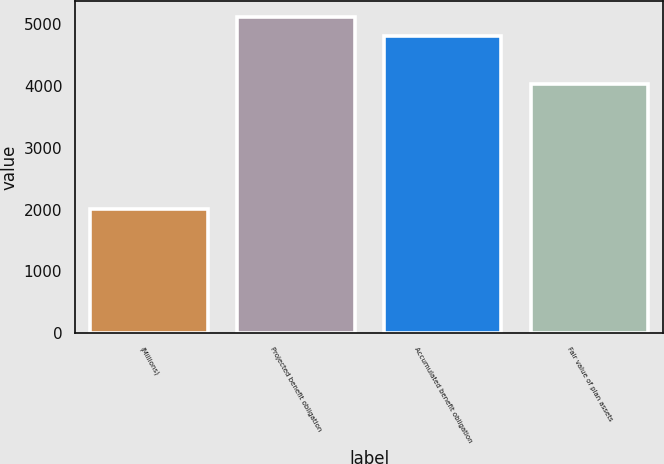Convert chart to OTSL. <chart><loc_0><loc_0><loc_500><loc_500><bar_chart><fcel>(Millions)<fcel>Projected benefit obligation<fcel>Accumulated benefit obligation<fcel>Fair value of plan assets<nl><fcel>2012<fcel>5122<fcel>4808<fcel>4038<nl></chart> 